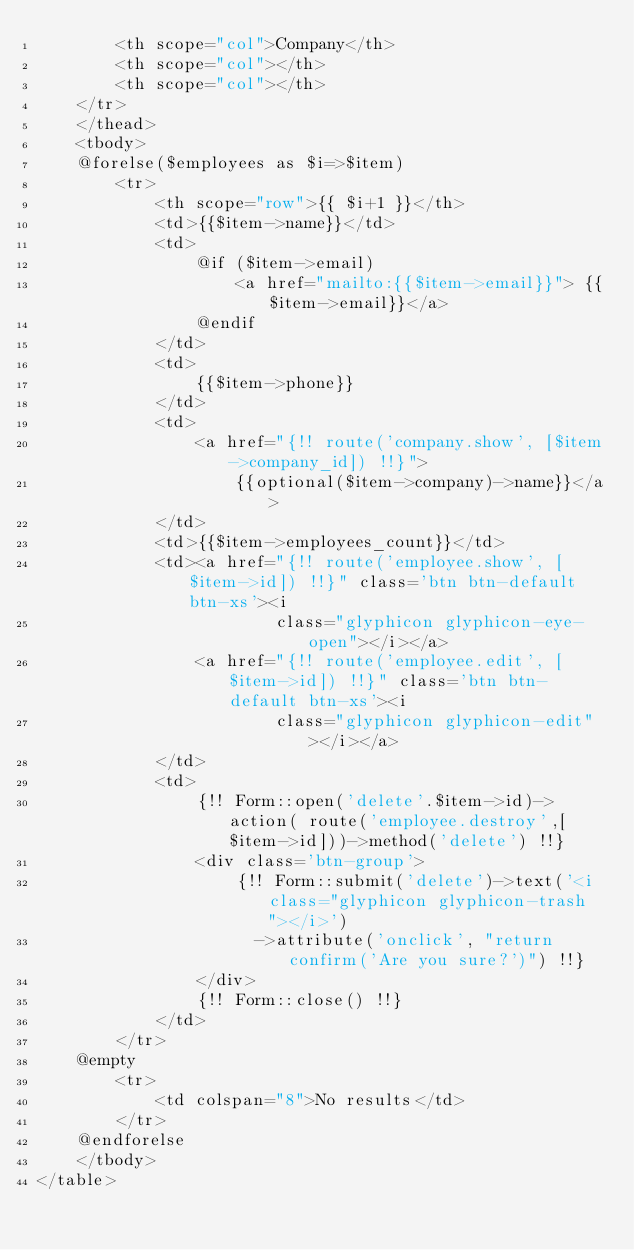<code> <loc_0><loc_0><loc_500><loc_500><_PHP_>        <th scope="col">Company</th>
        <th scope="col"></th>
        <th scope="col"></th>
    </tr>
    </thead>
    <tbody>
    @forelse($employees as $i=>$item)
        <tr>
            <th scope="row">{{ $i+1 }}</th>
            <td>{{$item->name}}</td>
            <td>
                @if ($item->email)
                    <a href="mailto:{{$item->email}}"> {{$item->email}}</a>
                @endif
            </td>
            <td>
                {{$item->phone}}
            </td>
            <td>
                <a href="{!! route('company.show', [$item->company_id]) !!}">
                    {{optional($item->company)->name}}</a>
            </td>
            <td>{{$item->employees_count}}</td>
            <td><a href="{!! route('employee.show', [$item->id]) !!}" class='btn btn-default btn-xs'><i
                        class="glyphicon glyphicon-eye-open"></i></a>
                <a href="{!! route('employee.edit', [$item->id]) !!}" class='btn btn-default btn-xs'><i
                        class="glyphicon glyphicon-edit"></i></a>
            </td>
            <td>
                {!! Form::open('delete'.$item->id)->action( route('employee.destroy',[$item->id]))->method('delete') !!}
                <div class='btn-group'>
                    {!! Form::submit('delete')->text('<i class="glyphicon glyphicon-trash"></i>')
                      ->attribute('onclick', "return confirm('Are you sure?')") !!}
                </div>
                {!! Form::close() !!}
            </td>
        </tr>
    @empty
        <tr>
            <td colspan="8">No results</td>
        </tr>
    @endforelse
    </tbody>
</table>
</code> 